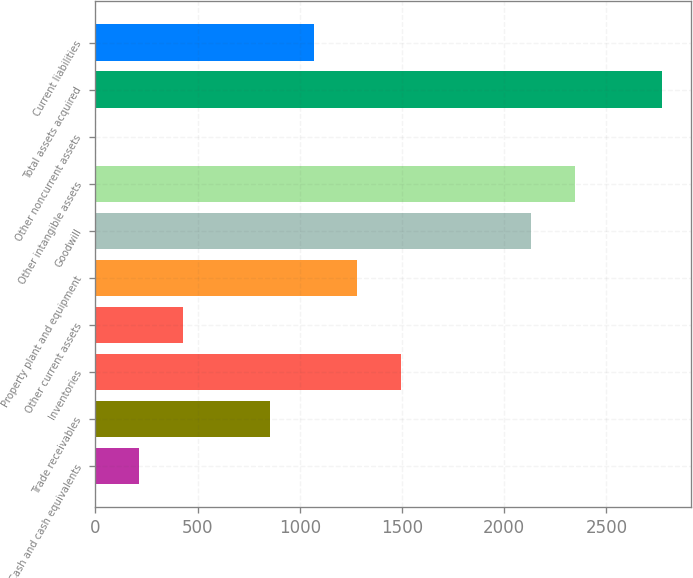<chart> <loc_0><loc_0><loc_500><loc_500><bar_chart><fcel>Cash and cash equivalents<fcel>Trade receivables<fcel>Inventories<fcel>Other current assets<fcel>Property plant and equipment<fcel>Goodwill<fcel>Other intangible assets<fcel>Other noncurrent assets<fcel>Total assets acquired<fcel>Current liabilities<nl><fcel>213.57<fcel>853.38<fcel>1493.19<fcel>426.84<fcel>1279.92<fcel>2133<fcel>2346.27<fcel>0.3<fcel>2772.81<fcel>1066.65<nl></chart> 